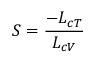Convert formula to latex. <formula><loc_0><loc_0><loc_500><loc_500>S = \frac { - L _ { c T } } { L _ { c V } }</formula> 